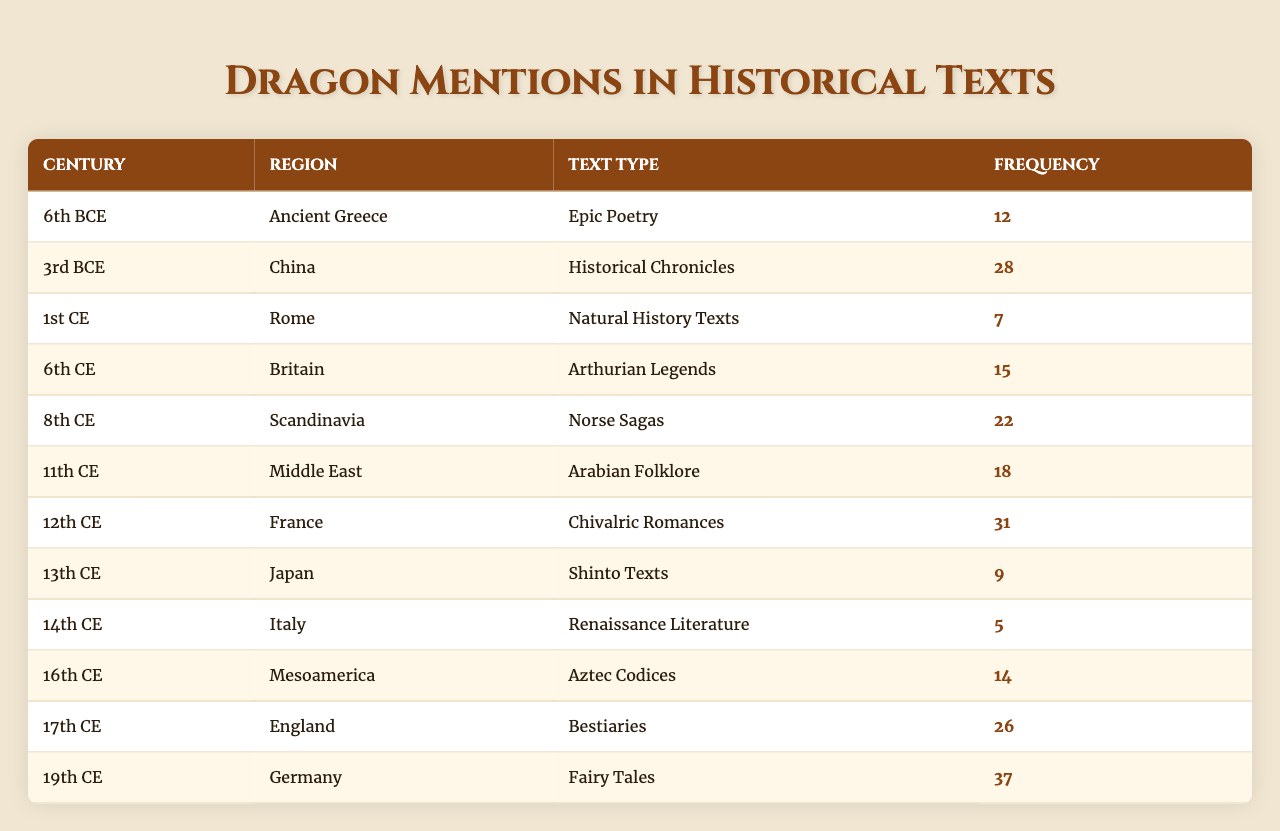What is the highest frequency of dragon mentions in a single text? The highest frequency in the table is found in the 19th CE in Germany with 37 mentions in "Fairy Tales."
Answer: 37 Which century had the lowest frequency of dragon mentions? The 14th CE in Italy had the lowest frequency, with only 5 mentions in "Renaissance Literature."
Answer: 5 Which region mentioned dragons most frequently in the 12th CE? In the 12th CE, France had the highest mentions with 31 occurrences in "Chivalric Romances."
Answer: France How many total mentions of dragons are there from the 6th BCE to the 6th CE? Adding data from the 6th BCE (12), 3rd BCE (28), 1st CE (7), and 6th CE (15) gives 12 + 28 + 7 + 15 = 62 total mentions.
Answer: 62 What is the difference in dragon mentions between China in the 3rd BCE and Germany in the 19th CE? China had 28 mentions in the 3rd BCE and Germany had 37 in the 19th CE, so the difference is 37 - 28 = 9.
Answer: 9 In which text type do we find the most frequent mentions of dragons in the 17th CE? In the 17th CE in England, the text type is "Bestiaries" with 26 mentions.
Answer: Bestiaries Calculate the average frequency of dragon mentions across all the centuries listed. The total frequency is 12 + 28 + 7 + 15 + 22 + 18 + 31 + 9 + 5 + 14 + 26 + 37 =  303. There are 12 entries, so the average is 303 / 12 = 25.25.
Answer: 25.25 Are there more mentions of dragons in the 12th CE compared to the 14th CE? Yes, the 12th CE has 31 mentions while the 14th CE has only 5, so there are significantly more in the former.
Answer: Yes Which century and region combination had 22 mentions? The 8th CE and Scandinavia had 22 mentions in "Norse Sagas."
Answer: 8th CE, Scandinavia What is the total frequency of dragon mentions in the texts from Britain and Germany? Britain recorded 15 mentions in the 6th CE, and Germany had 37 in the 19th CE, totaling 15 + 37 = 52 mentions.
Answer: 52 